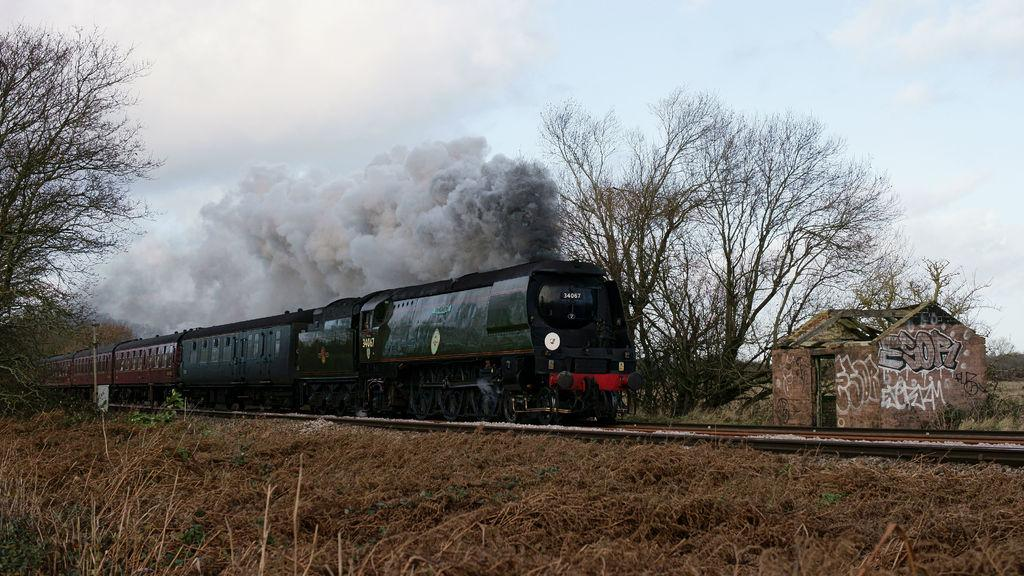What is the main subject of the image? The main subject of the image is a train. What is the train doing in the image? The train is moving on a track. What type of vegetation is visible in front of the train? There is dry grass in front of the train. What type of trees are visible behind the train? There are dry trees visible behind the train. What type of structure is located behind the train? There is a small shed house behind the train. What type of pancake is being cooked on the train's engine in the image? There is no pancake present in the image, nor is there any indication of cooking on the train's engine. 